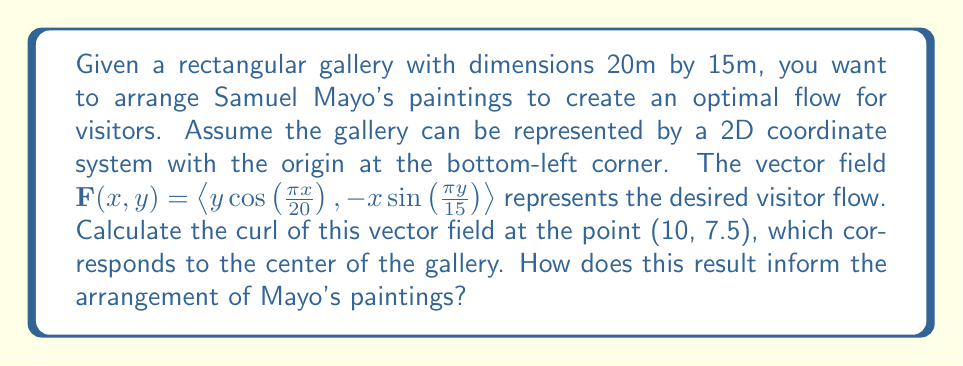Could you help me with this problem? To solve this problem, we'll follow these steps:

1) The curl of a vector field $\mathbf{F}(x,y) = \langle P(x,y), Q(x,y) \rangle$ in 2D is given by:

   $$\text{curl } \mathbf{F} = \frac{\partial Q}{\partial x} - \frac{\partial P}{\partial y}$$

2) In our case, $P(x,y) = y\cos(\frac{\pi x}{20})$ and $Q(x,y) = -x\sin(\frac{\pi y}{15})$

3) We need to calculate $\frac{\partial Q}{\partial x}$ and $\frac{\partial P}{\partial y}$:

   $$\frac{\partial Q}{\partial x} = -\sin(\frac{\pi y}{15})$$

   $$\frac{\partial P}{\partial y} = \cos(\frac{\pi x}{20})$$

4) Now we can calculate the curl:

   $$\text{curl } \mathbf{F} = -\sin(\frac{\pi y}{15}) - \cos(\frac{\pi x}{20})$$

5) We need to evaluate this at the point (10, 7.5):

   $$\text{curl } \mathbf{F}(10, 7.5) = -\sin(\frac{\pi \cdot 7.5}{15}) - \cos(\frac{\pi \cdot 10}{20})$$
   
   $$= -\sin(\frac{\pi}{2}) - \cos(\frac{\pi}{2}) = -1 - 0 = -1$$

6) The negative curl at the center indicates a clockwise rotation tendency in the flow. This suggests that Mayo's paintings should be arranged in a clockwise spiral pattern from the center outwards to align with the natural flow of visitors.
Answer: $-1$; arrange paintings in clockwise spiral from center. 